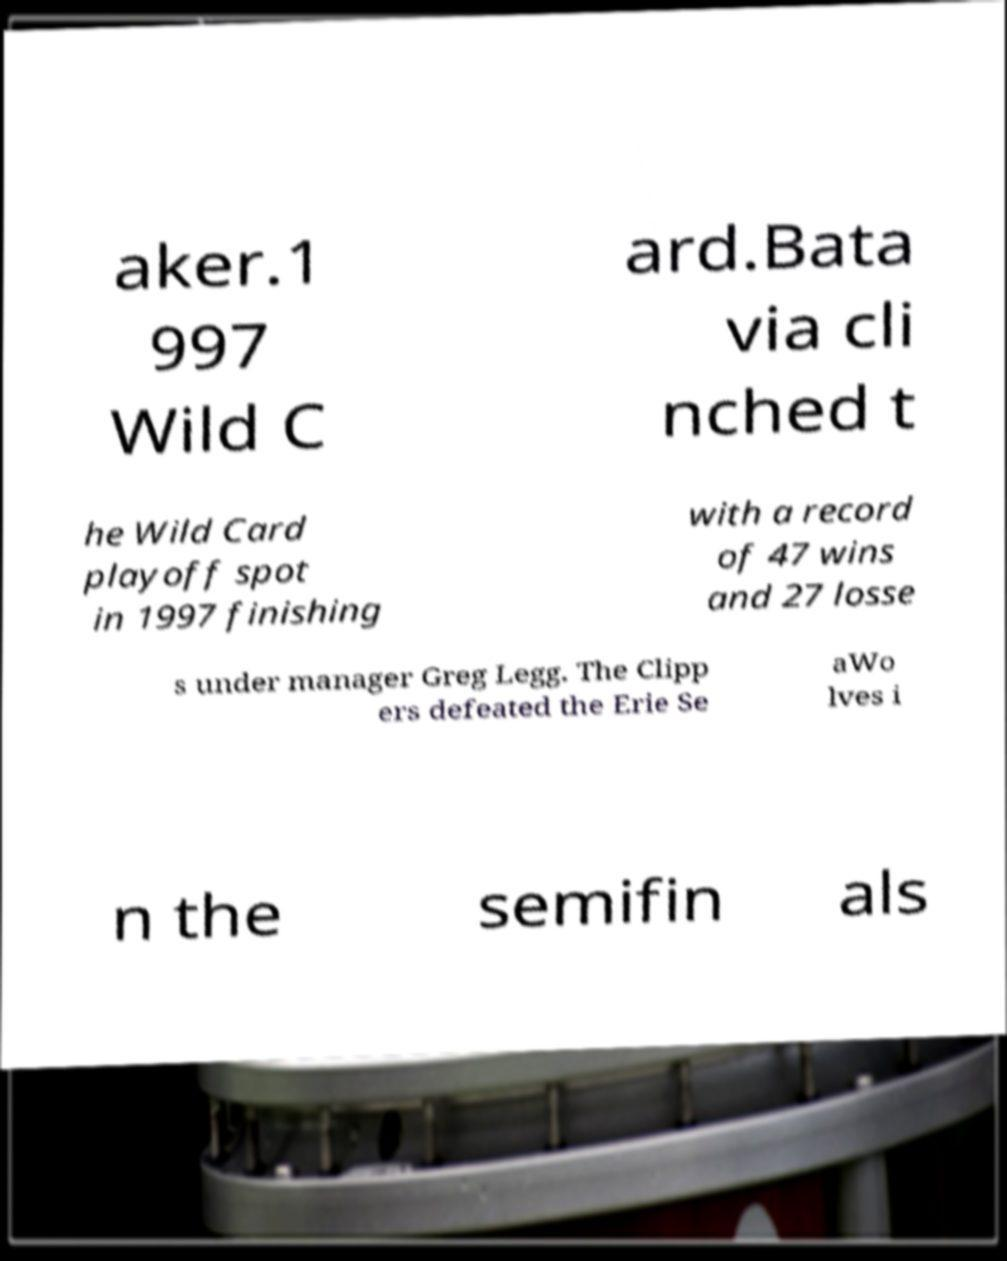There's text embedded in this image that I need extracted. Can you transcribe it verbatim? aker.1 997 Wild C ard.Bata via cli nched t he Wild Card playoff spot in 1997 finishing with a record of 47 wins and 27 losse s under manager Greg Legg. The Clipp ers defeated the Erie Se aWo lves i n the semifin als 